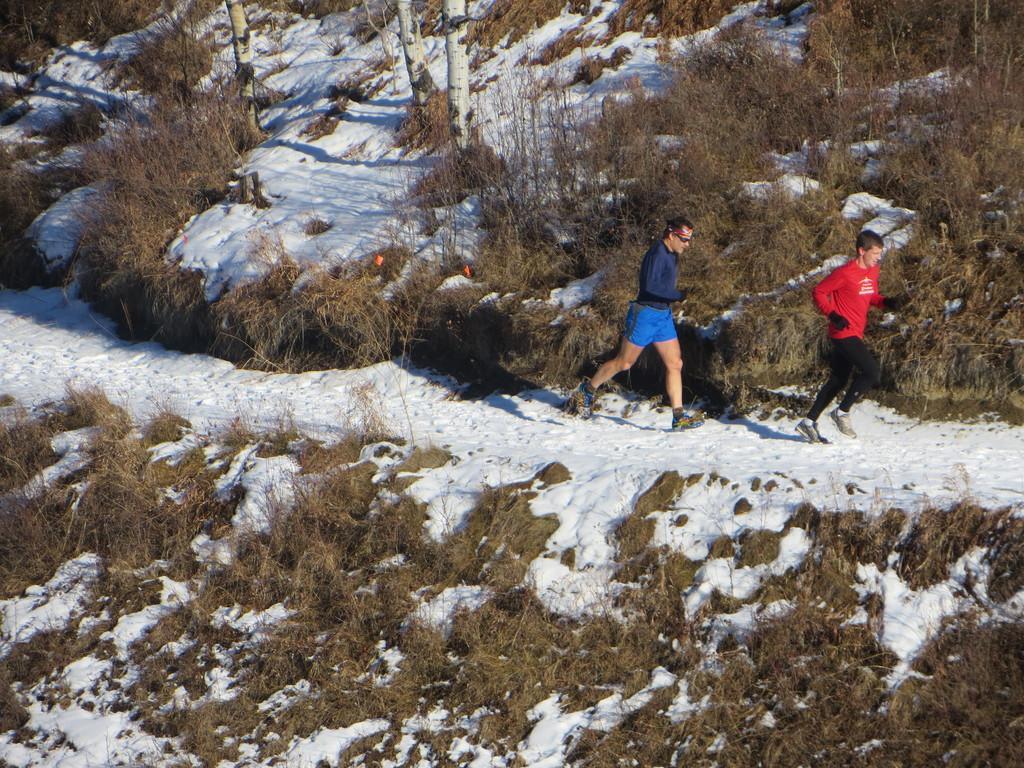Describe this image in one or two sentences. There are two persons running on the snow. On the ground there are plants and trees. 